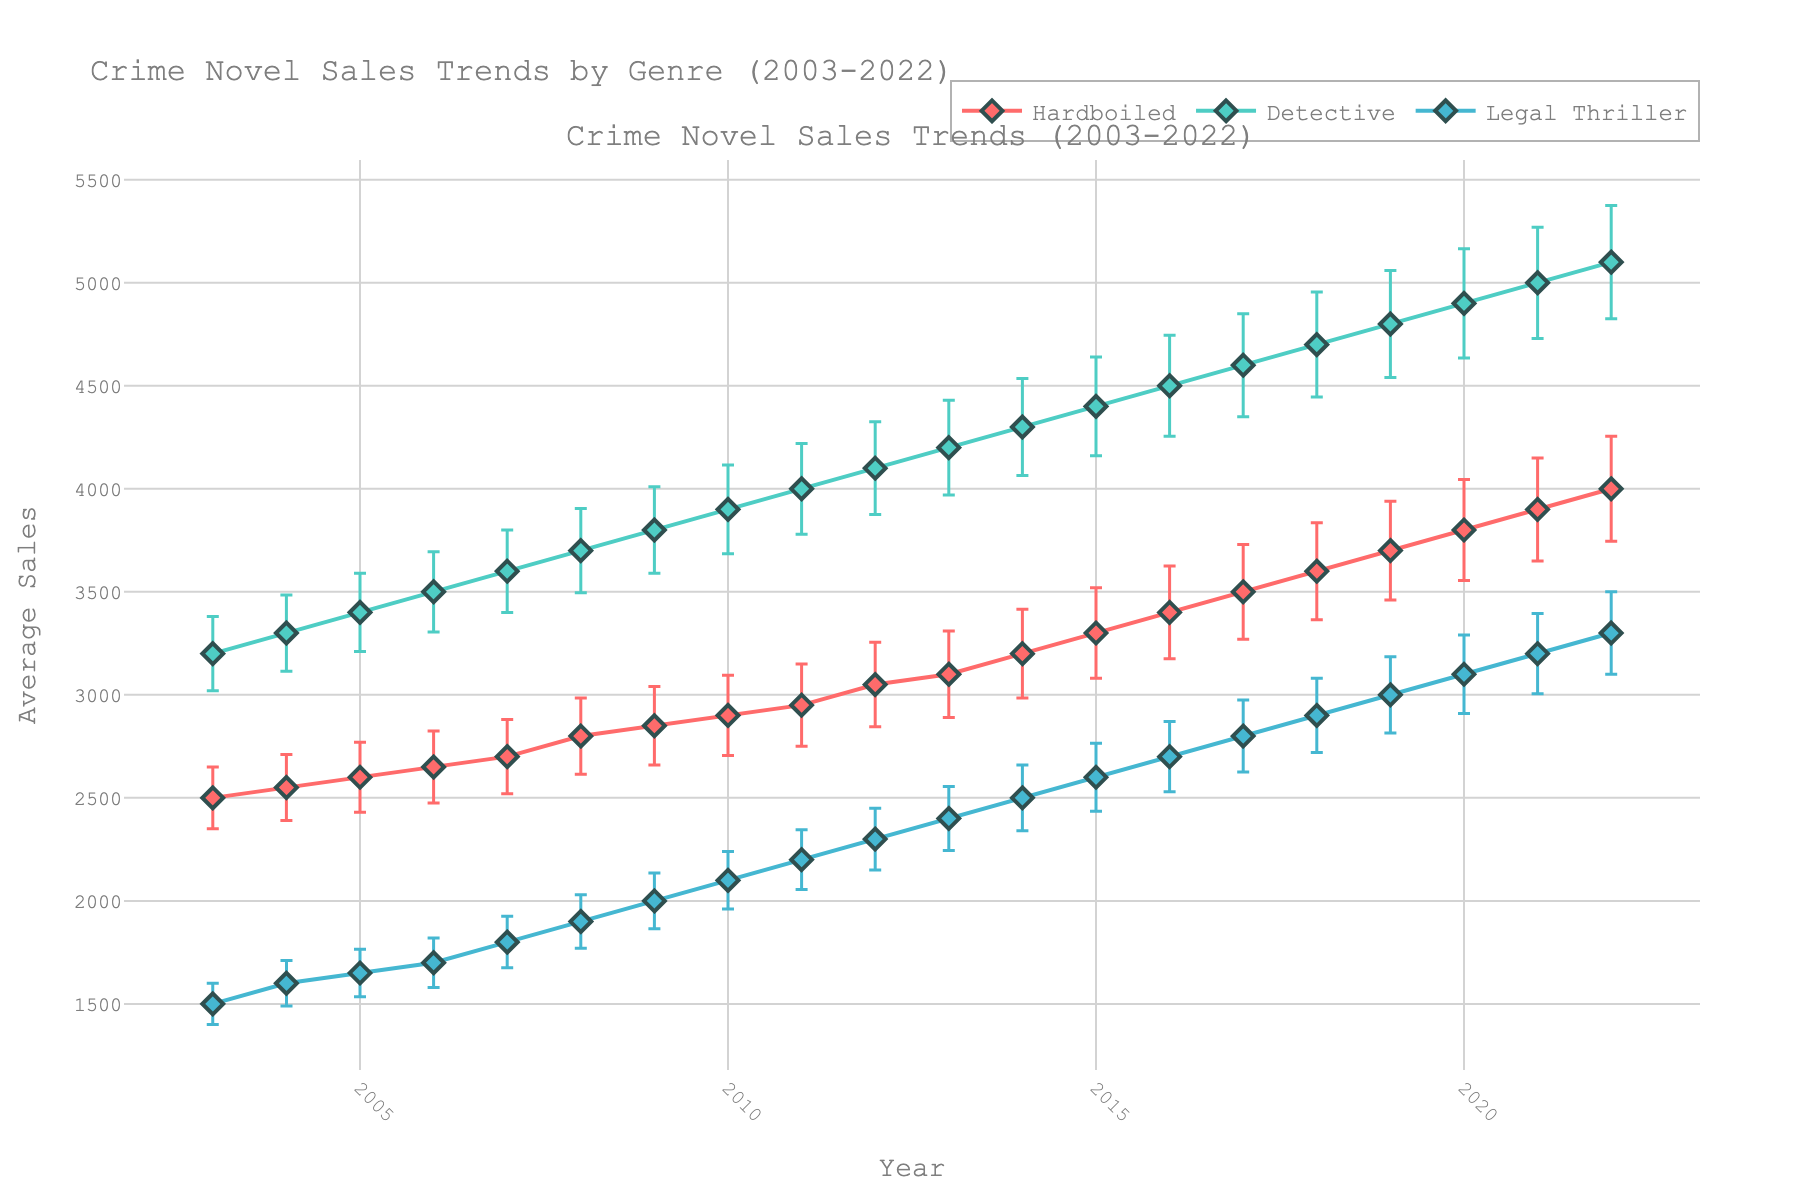What's the title of the figure? The title is usually displayed at the top of the plot. In this case, it reads "Crime Novel Sales Trends by Genre (2003-2022)."
Answer: Crime Novel Sales Trends by Genre (2003-2022) What is the color representation for the 'Hardboiled' genre? From the legend, we can see that 'Hardboiled' books are represented by a red line and markers.
Answer: Red Which year saw the highest average sales for 'Detective' novels? By observing the peaks of the 'Detective' line (aqua) along the x-axis, we identify that the highest point is in 2022.
Answer: 2022 How do the average sales of 'Legal Thriller' novels compare between 2003 and 2022? By comparing data points for 'Legal Thriller' (blue line) at 2003 and 2022 on the y-axis, average sales rise from 1500 to 3300.
Answer: Increased by 1800 What was the trend of 'Hardboiled' novel sales over the two decades? By following the red line from 2003 to 2022, we observe a consistent increase in sales for 'Hardboiled' novels.
Answer: Increasing Around which year did 'Legal Thriller' novels surpass 2000 in average sales? By identifying the crossing points on the 'Legal Thriller' line near 2000 sales, we see it occurred around 2011.
Answer: 2011 Compare the standard error bars for 'Detective' novels in 2003 and 2022. We see that the lengths of the error bars for 'Detective' novels increased significantly from 2003 (shorter) to 2022 (longer).
Answer: Increased What is the relationship between the trend lines for 'Hardboiled' and 'Detective' genres? Both lines (red for 'Hardboiled' and aqua for 'Detective') show upward trends, but 'Detective' novels start and end with higher average sales.
Answer: Both increasing, 'Detective' always higher Which genre had the smallest average sales variability based on error bars? By comparing the error bars' lengths, 'Legal Thriller' novels (blue line) generally have smaller bars.
Answer: Legal Thriller What genre saw the fastest growth rate over the given period? Comparing the steepness of all three lines, 'Detective' novels (aqua) show the steepest slope suggesting the fastest growth rate.
Answer: Detective 